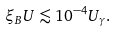<formula> <loc_0><loc_0><loc_500><loc_500>\xi _ { B } U \lesssim 1 0 ^ { - 4 } U _ { \gamma } .</formula> 